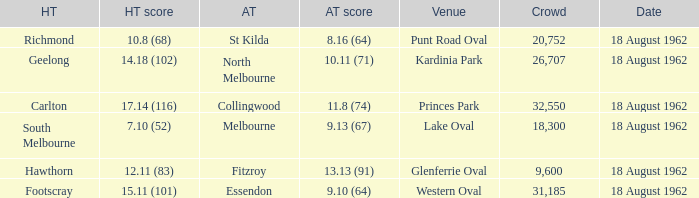What was the home team when the away team scored 9.10 (64)? Footscray. 